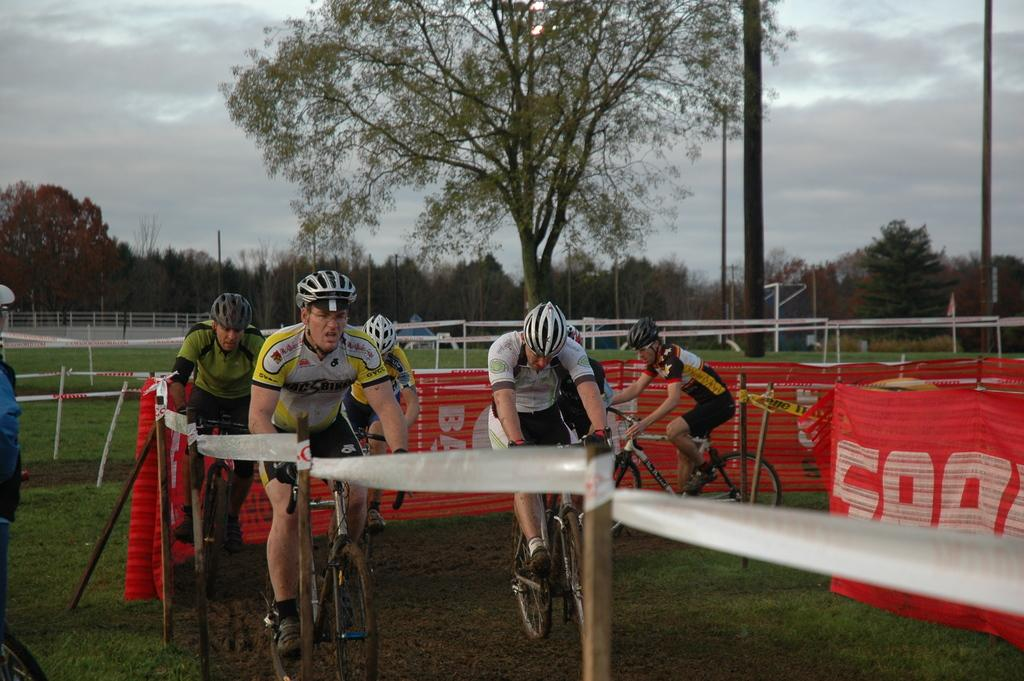What type of barrier can be seen in the image? There is a fence in the image. What decorative elements are present in the image? There are banners in the image. What activity are people engaged in within the image? People are cycling on the grass in the image. What type of vegetation is visible in the background of the image? There are trees in the background of the image. What architectural features can be seen in the background of the image? There are poles in the background of the image. What is visible in the sky in the image? The sky is visible in the background of the image. How many rocks are being carried by the men in the image? There are no men or rocks present in the image. What type of lead is being used by the people cycling in the image? There are no references to lead or any type of material being used by the people cycling in the image. 